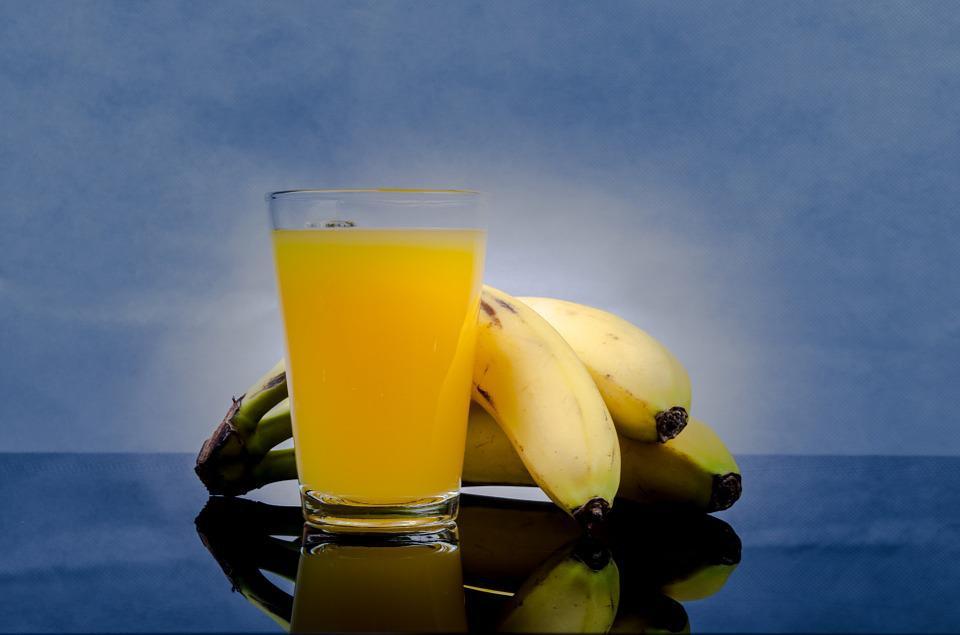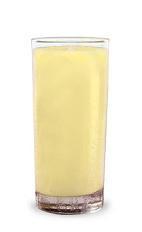The first image is the image on the left, the second image is the image on the right. Evaluate the accuracy of this statement regarding the images: "The right image contains at least one unpeeled banana.". Is it true? Answer yes or no. No. The first image is the image on the left, the second image is the image on the right. Evaluate the accuracy of this statement regarding the images: "There are pieces of bananas without peel near a glass of juice.". Is it true? Answer yes or no. No. 